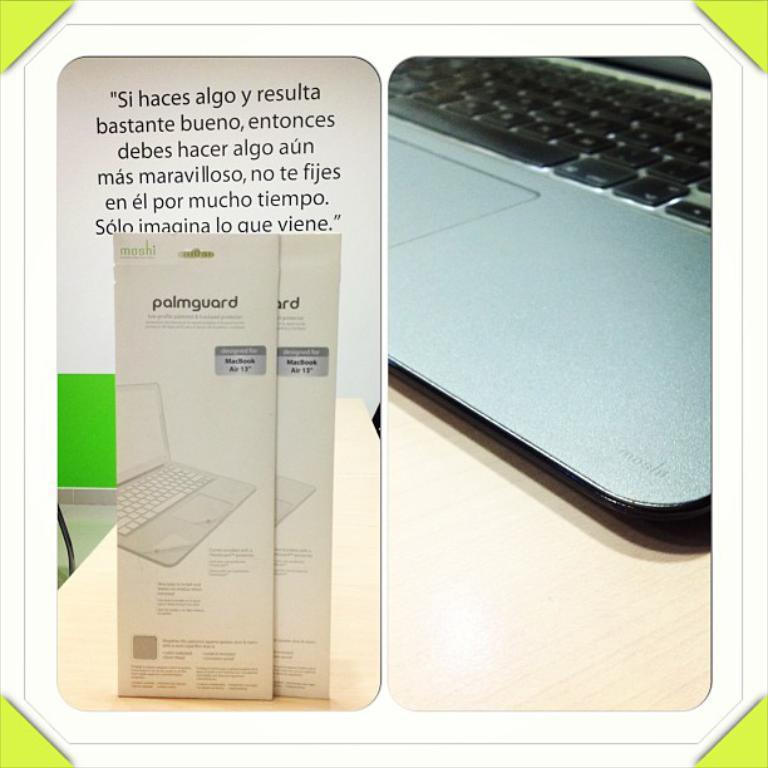<image>
Render a clear and concise summary of the photo. A product made for laptops that has foreign writing on it. 